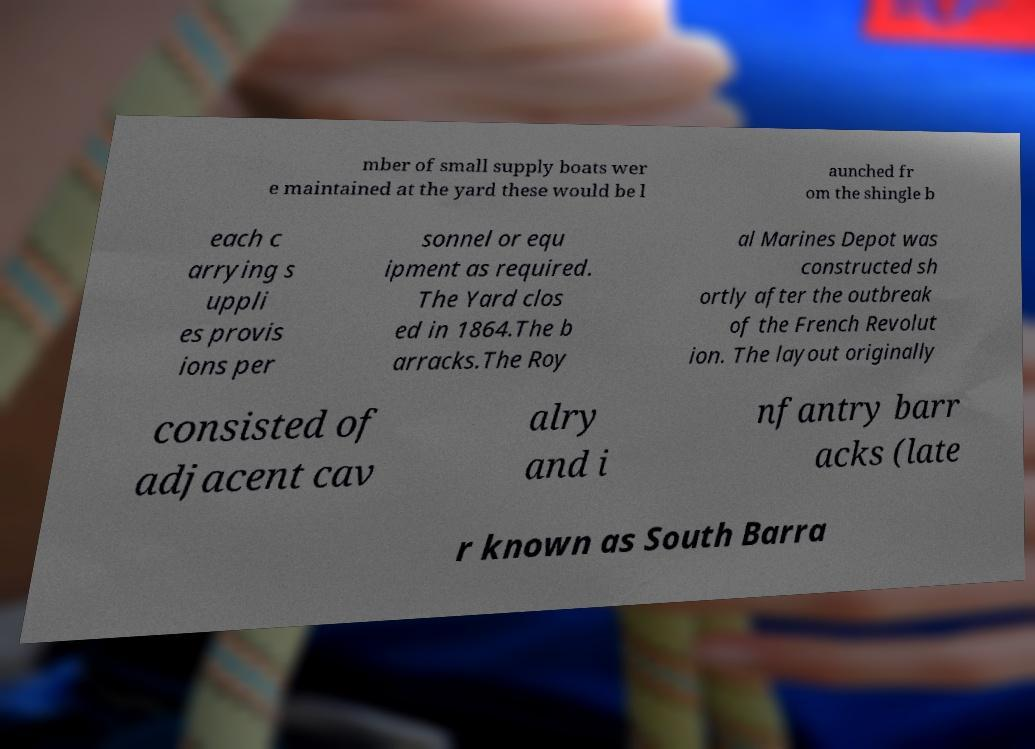Please identify and transcribe the text found in this image. mber of small supply boats wer e maintained at the yard these would be l aunched fr om the shingle b each c arrying s uppli es provis ions per sonnel or equ ipment as required. The Yard clos ed in 1864.The b arracks.The Roy al Marines Depot was constructed sh ortly after the outbreak of the French Revolut ion. The layout originally consisted of adjacent cav alry and i nfantry barr acks (late r known as South Barra 